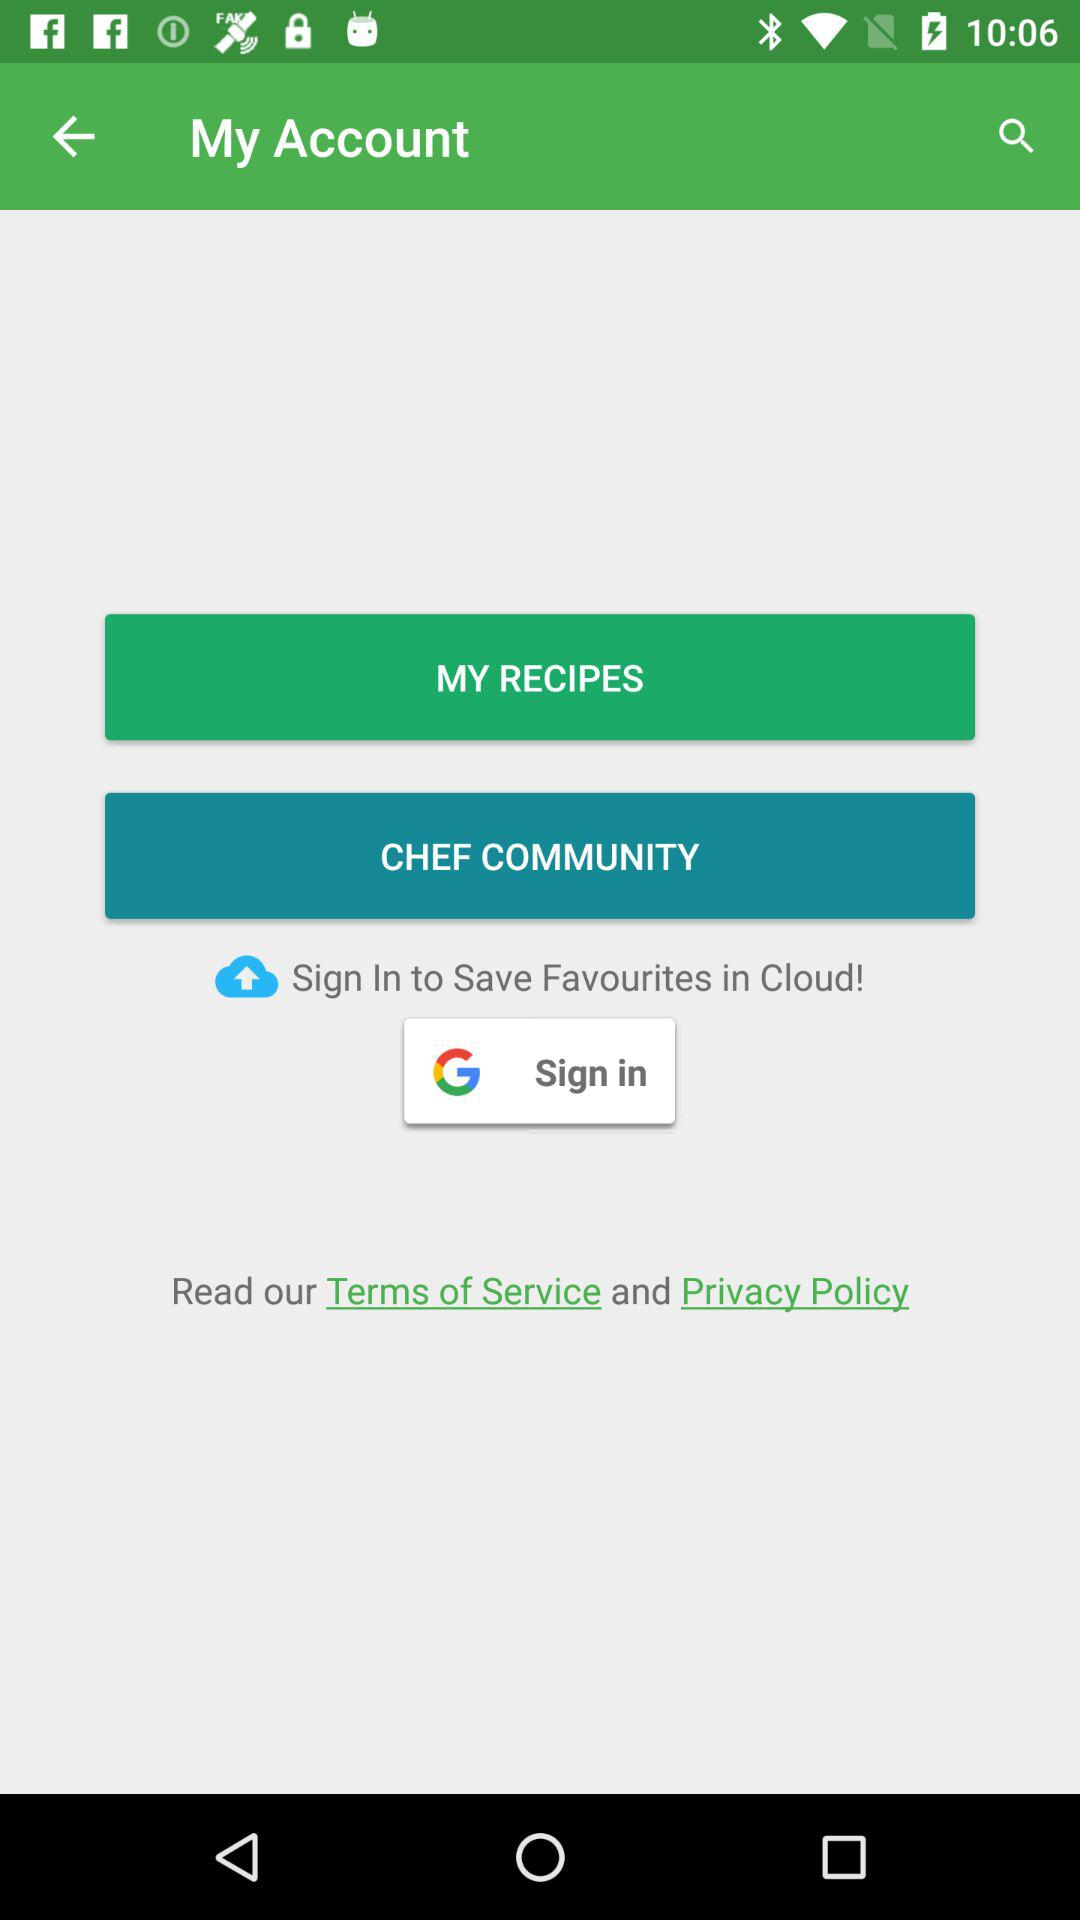Has the user agreed to the terms of service and privacy policy?
When the provided information is insufficient, respond with <no answer>. <no answer> 